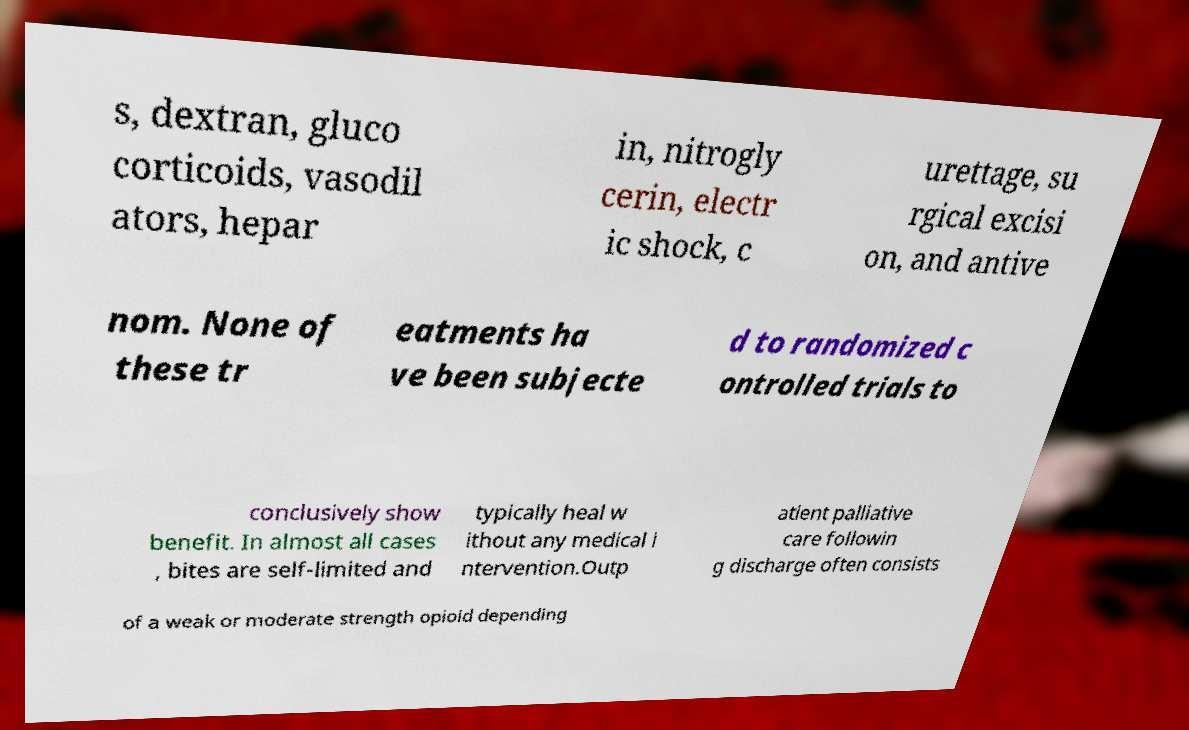Please read and relay the text visible in this image. What does it say? s, dextran, gluco corticoids, vasodil ators, hepar in, nitrogly cerin, electr ic shock, c urettage, su rgical excisi on, and antive nom. None of these tr eatments ha ve been subjecte d to randomized c ontrolled trials to conclusively show benefit. In almost all cases , bites are self-limited and typically heal w ithout any medical i ntervention.Outp atient palliative care followin g discharge often consists of a weak or moderate strength opioid depending 